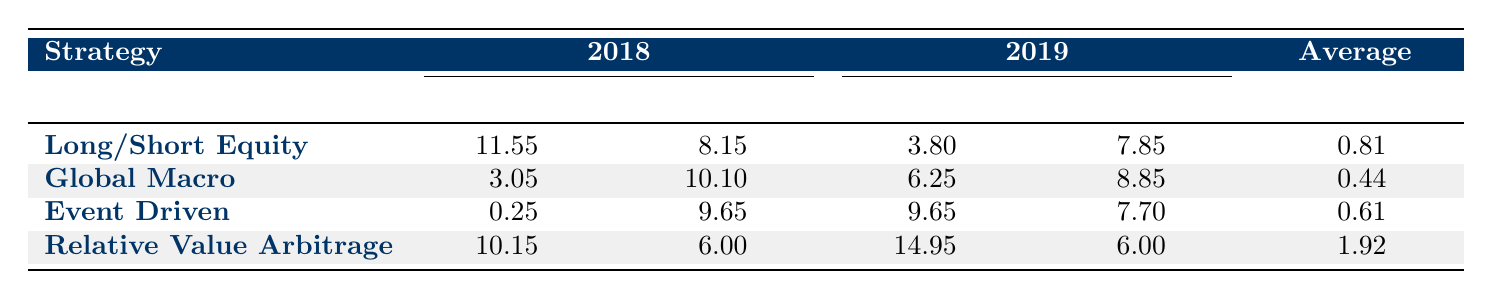What is the return of Long/Short Equity in 2018? The table shows the return for Long/Short Equity in 2018 as 11.55 percent.
Answer: 11.55% What is the average volatility for Relative Value Arbitrage across both years? For Relative Value Arbitrage, the volatility in 2018 is 6.00 percent and in 2019 is also 6.00 percent. The average is calculated as (6.00 + 6.00) / 2 = 6.00 percent.
Answer: 6.00% Did the Event Driven strategy have a positive return in both years? In 2018, the return for Event Driven is 0.25 percent, which is positive, but in 2019 it is 9.65 percent, which is also positive. Therefore, the answer is yes.
Answer: Yes Which strategy had the highest average Sharpe Ratio? The average Sharpe Ratios for each strategy are: Long/Short Equity 0.81, Global Macro 0.44, Event Driven 0.61, Relative Value Arbitrage 1.92. Since 1.92 is the highest, Relative Value Arbitrage has the highest average Sharpe Ratio.
Answer: Relative Value Arbitrage What is the difference in return between Global Macro in 2019 and Long/Short Equity in 2018? The return for Global Macro in 2019 is 6.25 percent, and the return for Long/Short Equity in 2018 is 11.55 percent. The difference is calculated as 11.55 - 6.25 = 5.30 percent.
Answer: 5.30% 